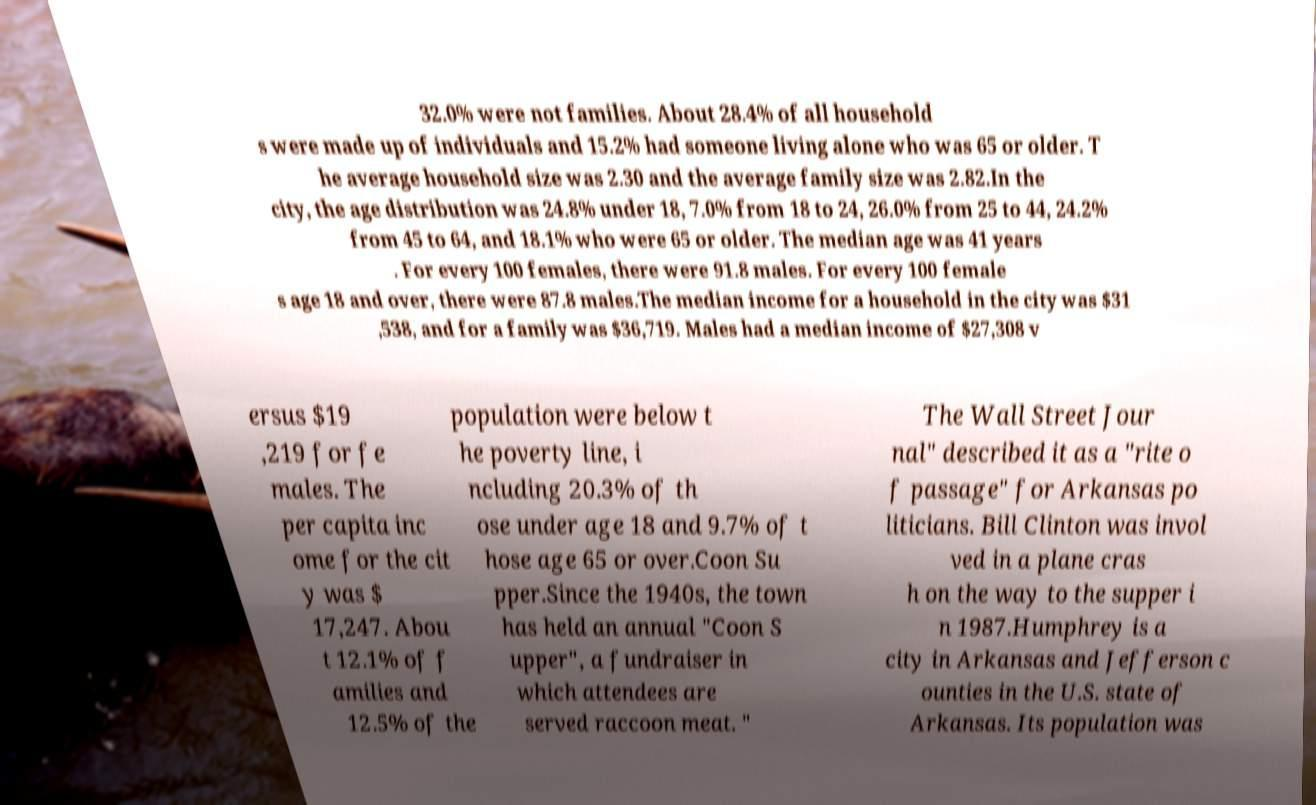I need the written content from this picture converted into text. Can you do that? 32.0% were not families. About 28.4% of all household s were made up of individuals and 15.2% had someone living alone who was 65 or older. T he average household size was 2.30 and the average family size was 2.82.In the city, the age distribution was 24.8% under 18, 7.0% from 18 to 24, 26.0% from 25 to 44, 24.2% from 45 to 64, and 18.1% who were 65 or older. The median age was 41 years . For every 100 females, there were 91.8 males. For every 100 female s age 18 and over, there were 87.8 males.The median income for a household in the city was $31 ,538, and for a family was $36,719. Males had a median income of $27,308 v ersus $19 ,219 for fe males. The per capita inc ome for the cit y was $ 17,247. Abou t 12.1% of f amilies and 12.5% of the population were below t he poverty line, i ncluding 20.3% of th ose under age 18 and 9.7% of t hose age 65 or over.Coon Su pper.Since the 1940s, the town has held an annual "Coon S upper", a fundraiser in which attendees are served raccoon meat. " The Wall Street Jour nal" described it as a "rite o f passage" for Arkansas po liticians. Bill Clinton was invol ved in a plane cras h on the way to the supper i n 1987.Humphrey is a city in Arkansas and Jefferson c ounties in the U.S. state of Arkansas. Its population was 